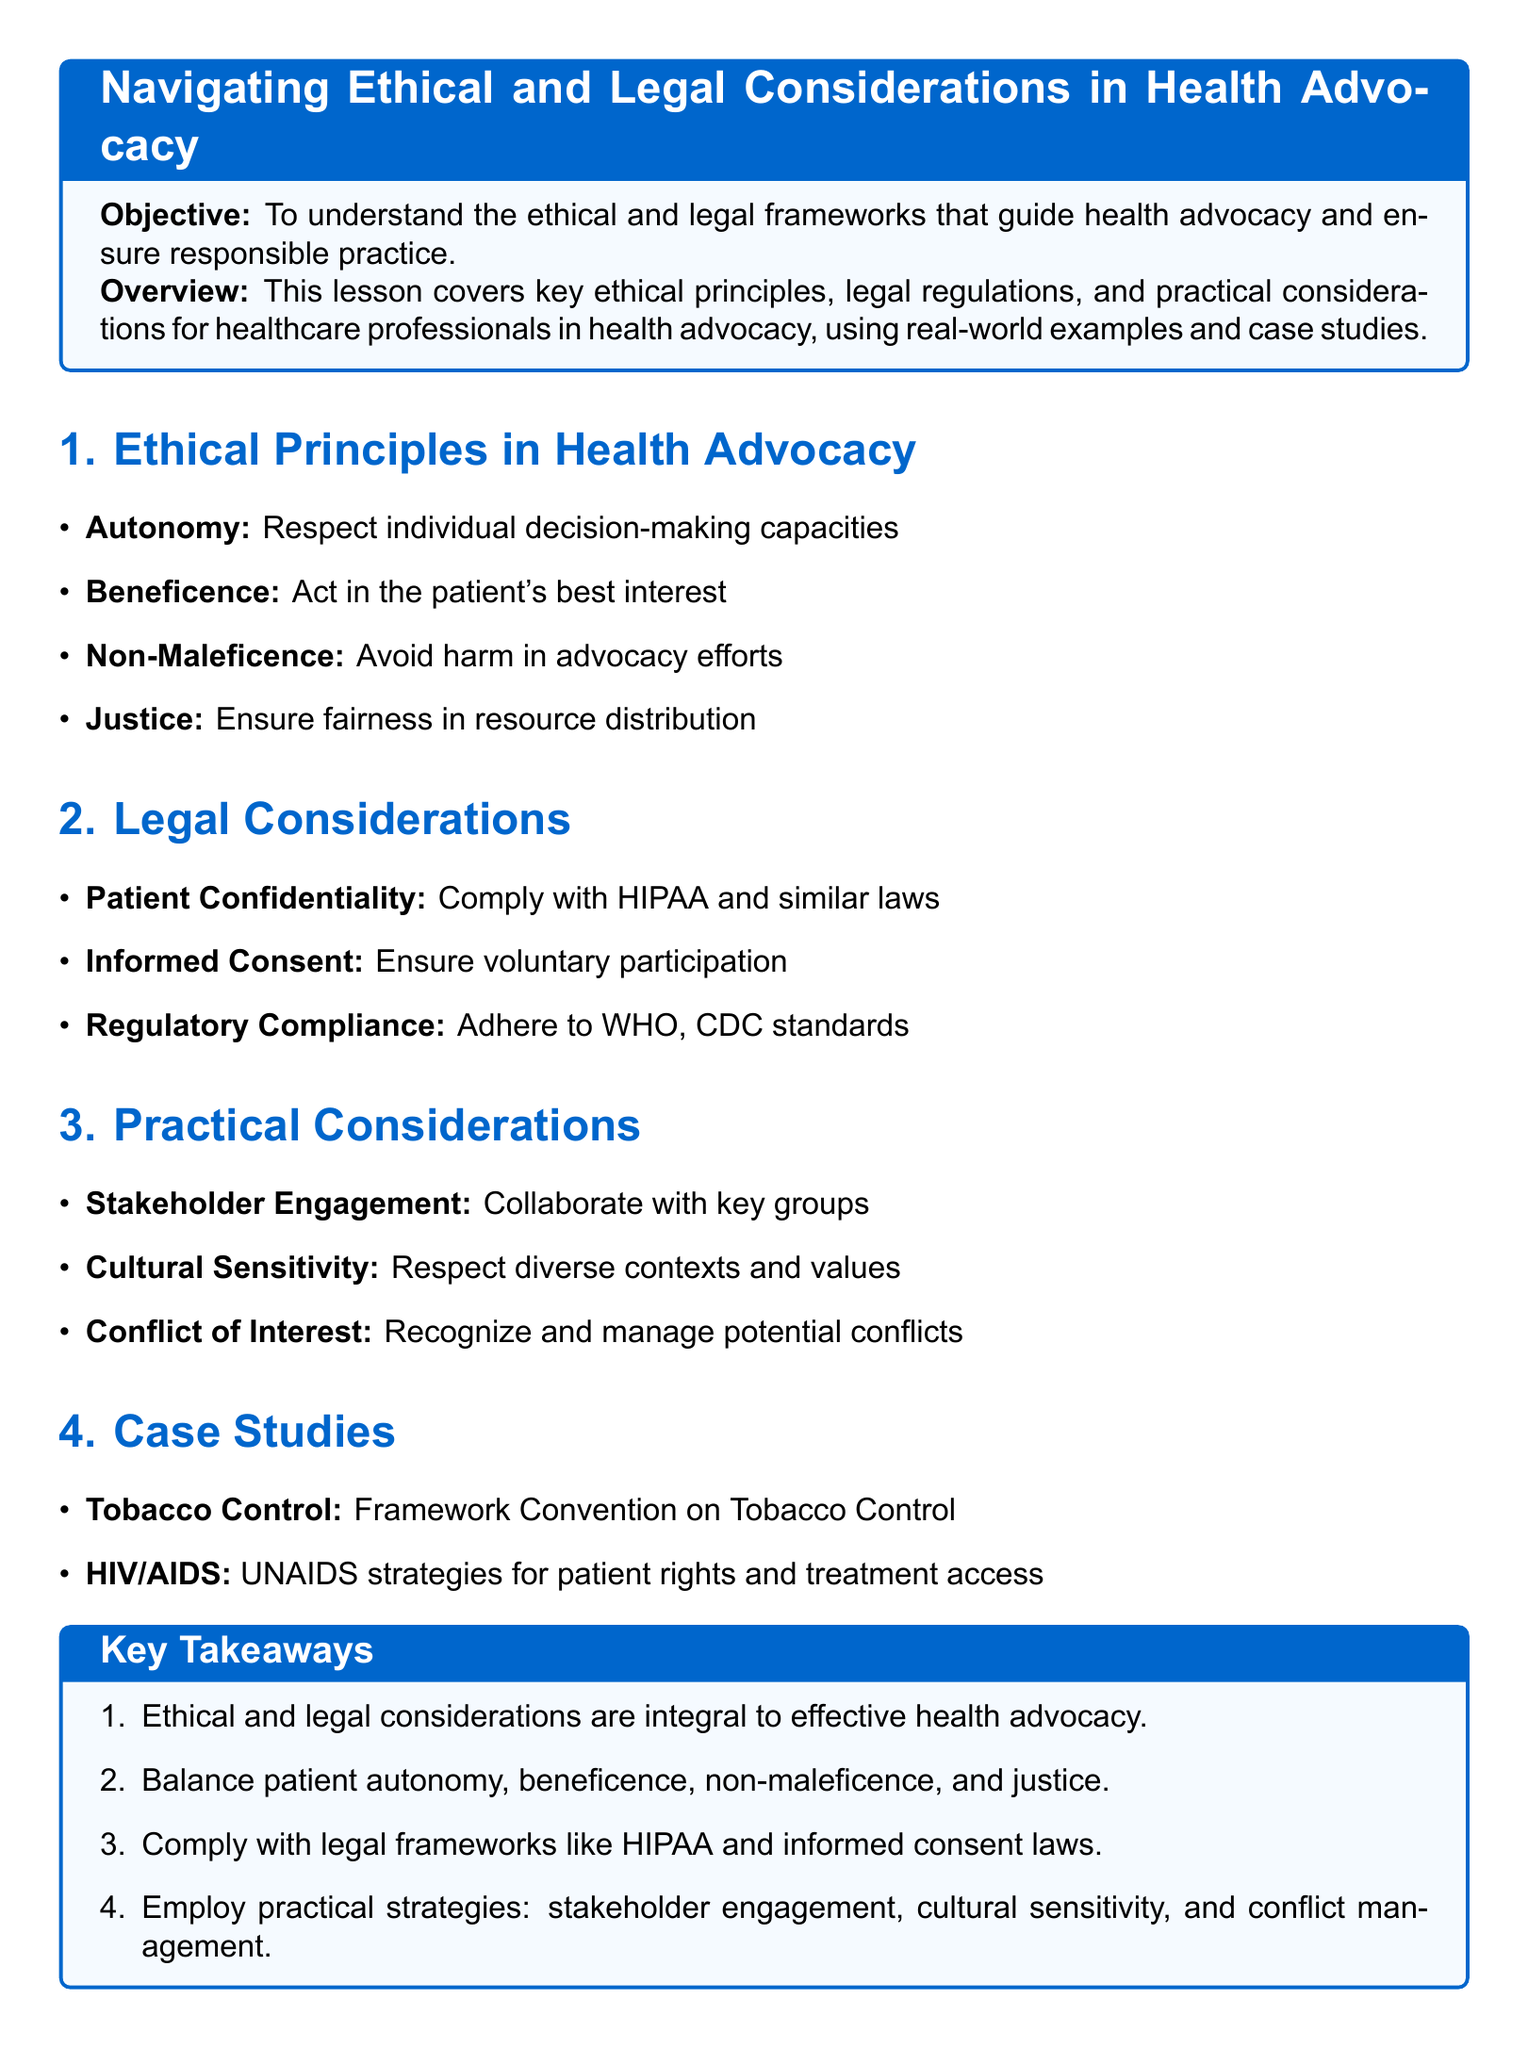What is the objective of the lesson? The objective is stated clearly within the document, emphasizing the understanding of ethical and legal frameworks in health advocacy.
Answer: To understand the ethical and legal frameworks that guide health advocacy and ensure responsible practice What are the four ethical principles listed? The document lists four key ethical principles relevant to health advocacy.
Answer: Autonomy, Beneficence, Non-Maleficence, Justice Which law is mentioned in relation to patient confidentiality? The law referenced pertains to patient confidentiality in health advocacy, ensuring the protection of patient information.
Answer: HIPAA What is emphasized as a practical consideration during advocacy? The document discusses various practical strategies, one of which is critical for successful advocacy efforts.
Answer: Stakeholder Engagement Name one of the case studies presented. The document provides two case studies as examples, highlighting significant health issues and responses.
Answer: Tobacco Control How many key takeaways are summarized in the lesson? The lesson plan concludes with a summary that lists key points for better understanding and recall.
Answer: Four 